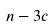Convert formula to latex. <formula><loc_0><loc_0><loc_500><loc_500>n - 3 c</formula> 